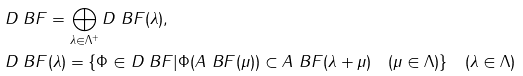<formula> <loc_0><loc_0><loc_500><loc_500>& D _ { \ } B F = \bigoplus _ { \lambda \in \Lambda ^ { + } } D _ { \ } B F ( \lambda ) , \\ & D _ { \ } B F ( \lambda ) = \{ \Phi \in D _ { \ } B F | \Phi ( A _ { \ } B F ( \mu ) ) \subset A _ { \ } B F ( \lambda + \mu ) \quad ( \mu \in \Lambda ) \} \quad ( \lambda \in \Lambda )</formula> 